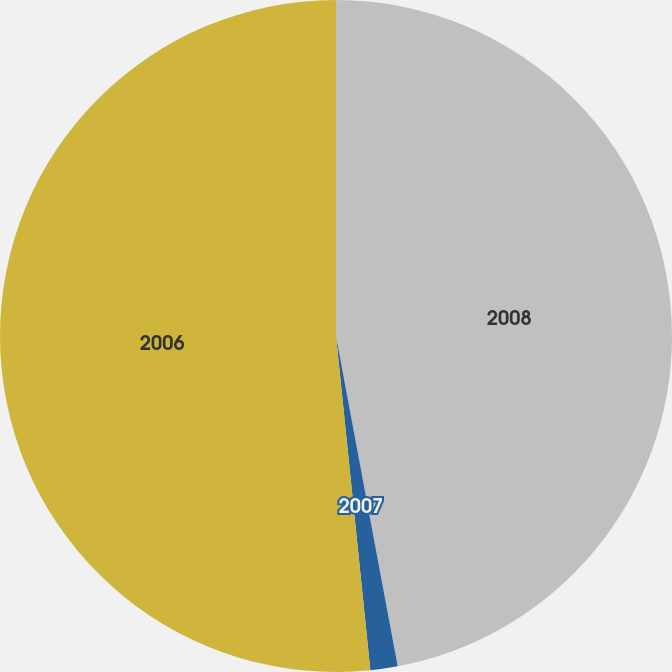Convert chart. <chart><loc_0><loc_0><loc_500><loc_500><pie_chart><fcel>2008<fcel>2007<fcel>2006<nl><fcel>47.06%<fcel>1.31%<fcel>51.63%<nl></chart> 